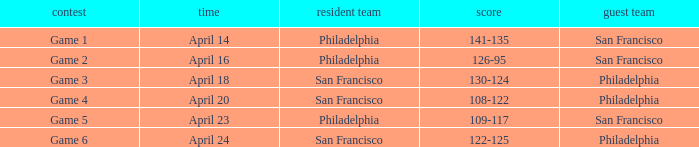What was the result of the game played on April 16 with Philadelphia as home team? 126-95. 